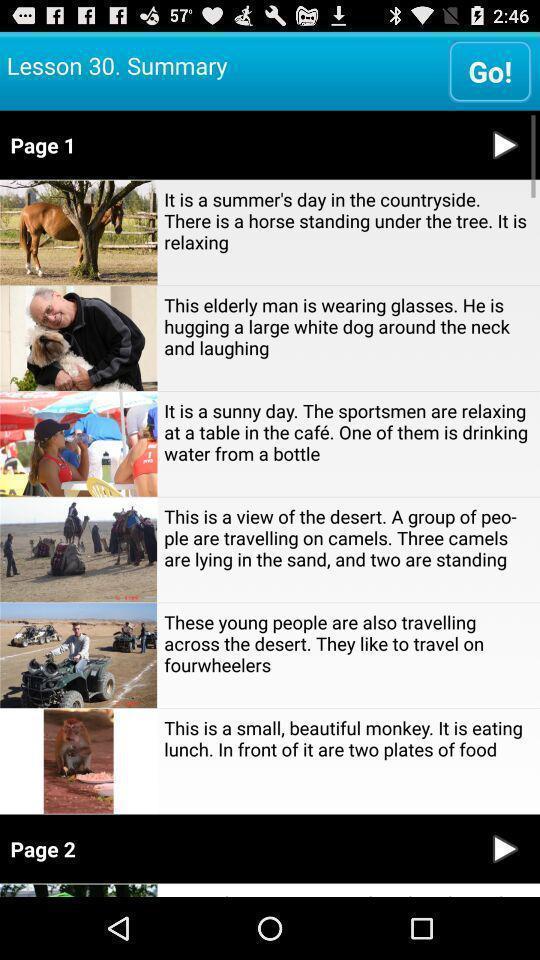Explain the elements present in this screenshot. Screen display about lessons in a language learning application. 